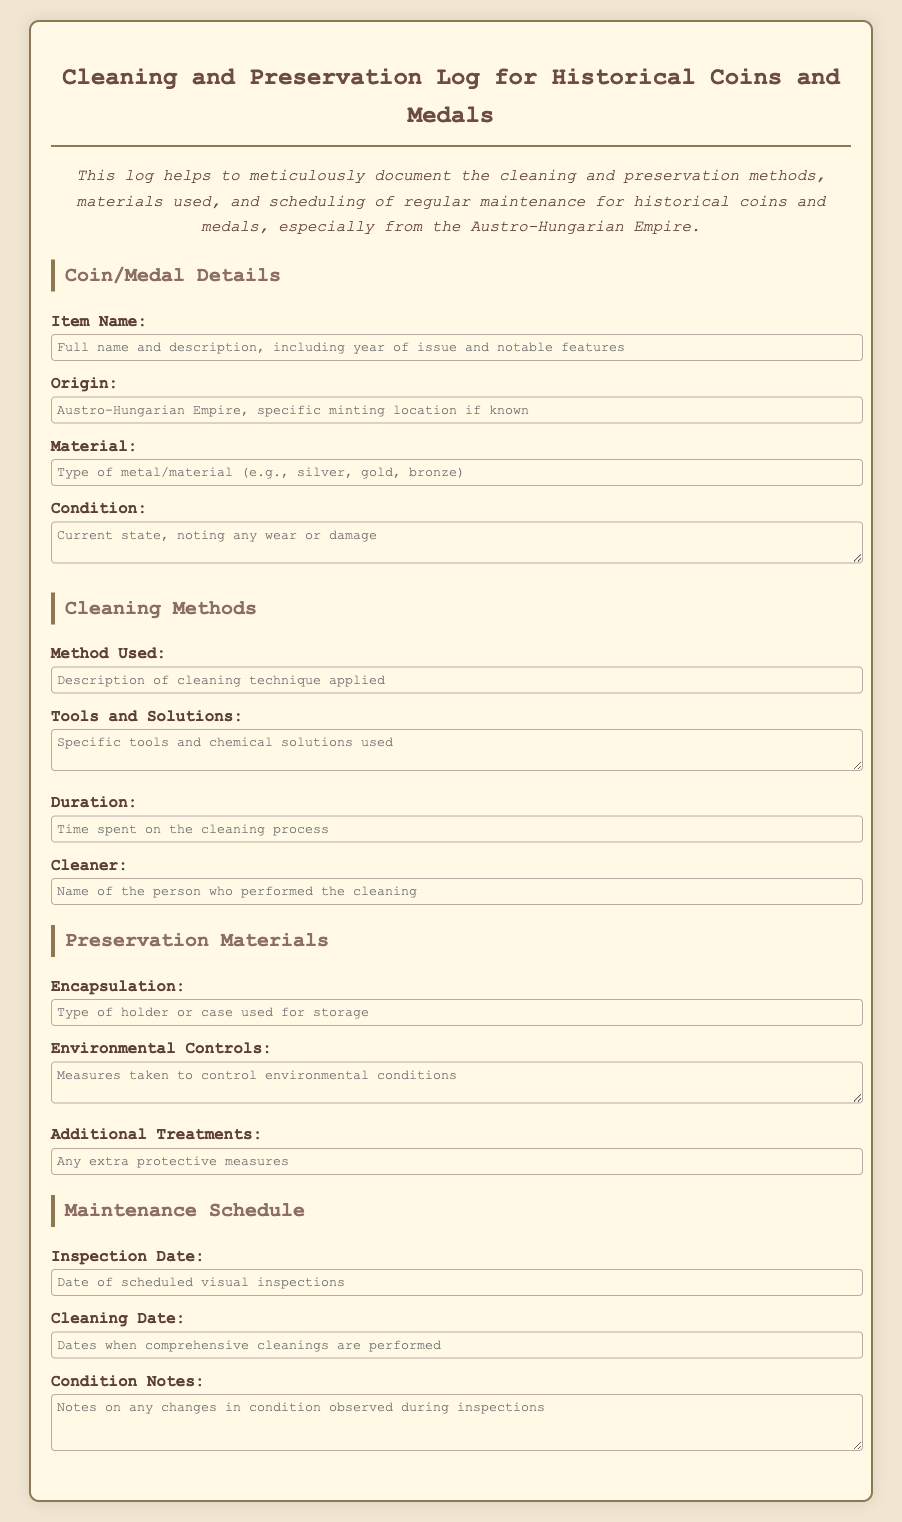what is the title of the document? The title of the document is indicated at the top of the rendered page.
Answer: Cleaning and Preservation Log for Historical Coins and Medals what is the purpose of this log? The purpose of the log is described in the introductory paragraph, outlining its use for documentation.
Answer: To meticulously document the cleaning and preservation methods what type of material is mentioned for the coins and medals? The type of material can be found in the details section of the document.
Answer: metal/material who performed the cleaning? The name of the person who performed the cleaning is recorded in the cleaning methods section.
Answer: Cleaner what should be noted during inspections? This information is included in the maintenance schedule section under condition notes.
Answer: Changes in condition observed what aspect does "environmental controls" address? The text describes measures taken to control environmental conditions, indicating its significance in preservation.
Answer: Control environmental conditions when is the inspection date scheduled? The inspection date is described in detail under the maintenance schedule section.
Answer: Inspection Date what type of holder is used for storage? The type of holder is specified in the preservation materials section.
Answer: Encapsulation what is the current state of coins and medals? The current state is noted in the condition field of the coin/medal details section.
Answer: Condition 